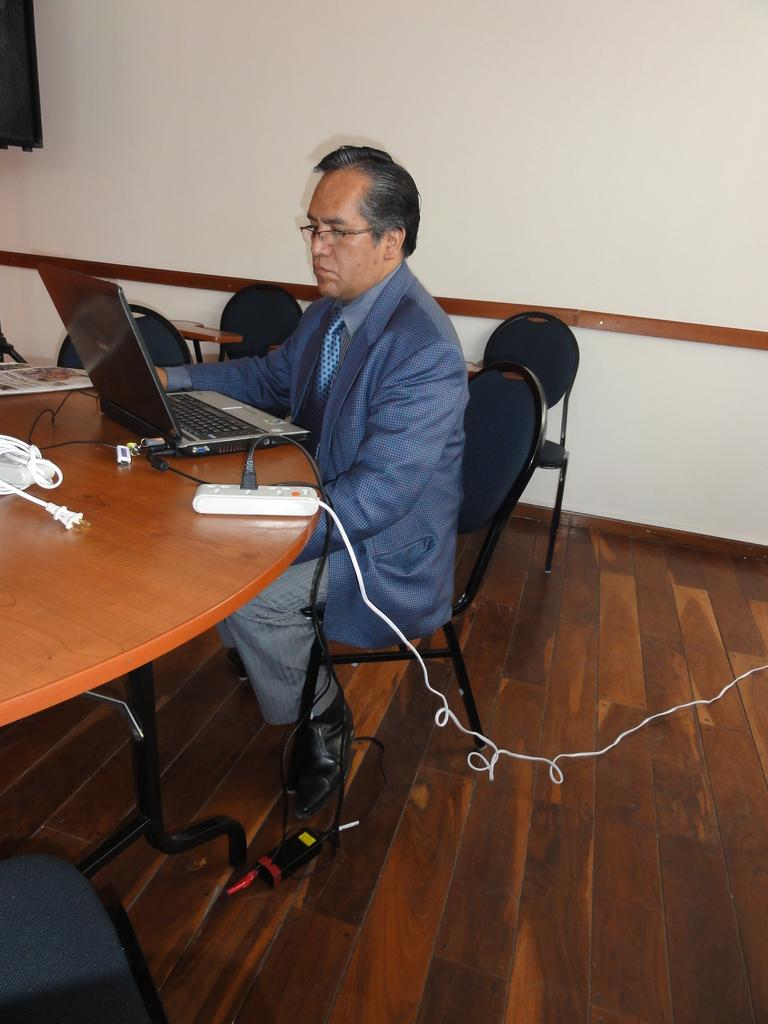Who is present in the image? There is a man in the image. What is the man wearing? The man is wearing a suit. What is the man doing in the image? The man is sitting on a chair and using a laptop. Where is the laptop located? The laptop is on a table. What is the floor made of? The floor is made of wood. What type of area does the setting appear to be? The setting appears to be a meeting area. What type of rainstorm can be seen in the image? There is no rainstorm present in the image; it is an indoor setting with a man sitting on a chair and using a laptop. What direction is the current flowing in the image? There is no reference to a current or water flow in the image. 